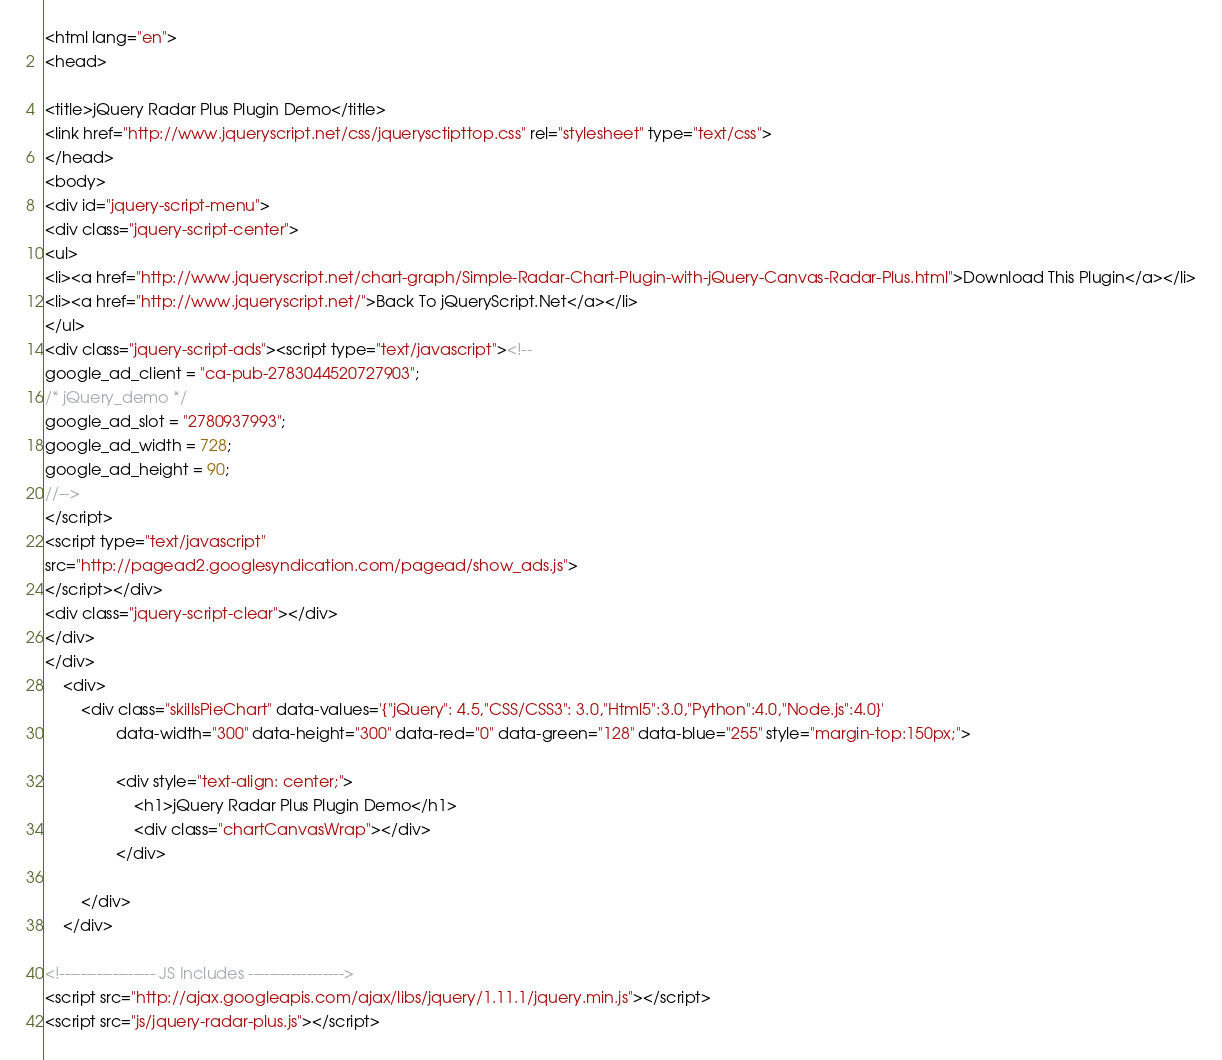Convert code to text. <code><loc_0><loc_0><loc_500><loc_500><_HTML_><html lang="en">
<head>

<title>jQuery Radar Plus Plugin Demo</title>
<link href="http://www.jqueryscript.net/css/jquerysctipttop.css" rel="stylesheet" type="text/css">
</head>
<body>
<div id="jquery-script-menu">
<div class="jquery-script-center">
<ul>
<li><a href="http://www.jqueryscript.net/chart-graph/Simple-Radar-Chart-Plugin-with-jQuery-Canvas-Radar-Plus.html">Download This Plugin</a></li>
<li><a href="http://www.jqueryscript.net/">Back To jQueryScript.Net</a></li>
</ul>
<div class="jquery-script-ads"><script type="text/javascript"><!--
google_ad_client = "ca-pub-2783044520727903";
/* jQuery_demo */
google_ad_slot = "2780937993";
google_ad_width = 728;
google_ad_height = 90;
//-->
</script>
<script type="text/javascript"
src="http://pagead2.googlesyndication.com/pagead/show_ads.js">
</script></div>
<div class="jquery-script-clear"></div>
</div>
</div>
	<div>
		<div class="skillsPieChart" data-values='{"jQuery": 4.5,"CSS/CSS3": 3.0,"Html5":3.0,"Python":4.0,"Node.js":4.0}'
				data-width="300" data-height="300" data-red="0" data-green="128" data-blue="255" style="margin-top:150px;">
				
				<div style="text-align: center;">
					<h1>jQuery Radar Plus Plugin Demo</h1>
					<div class="chartCanvasWrap"></div>
				</div>
				
		</div>
	</div>

<!------------------ JS Includes ------------------>
<script src="http://ajax.googleapis.com/ajax/libs/jquery/1.11.1/jquery.min.js"></script>
<script src="js/jquery-radar-plus.js"></script></code> 